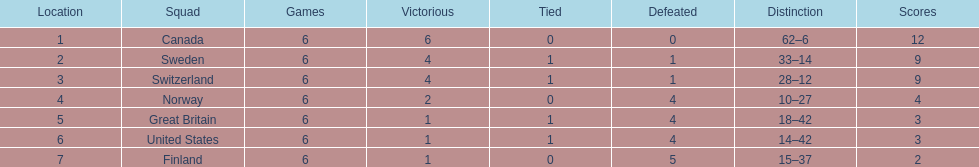Which country conceded the least goals? Finland. 